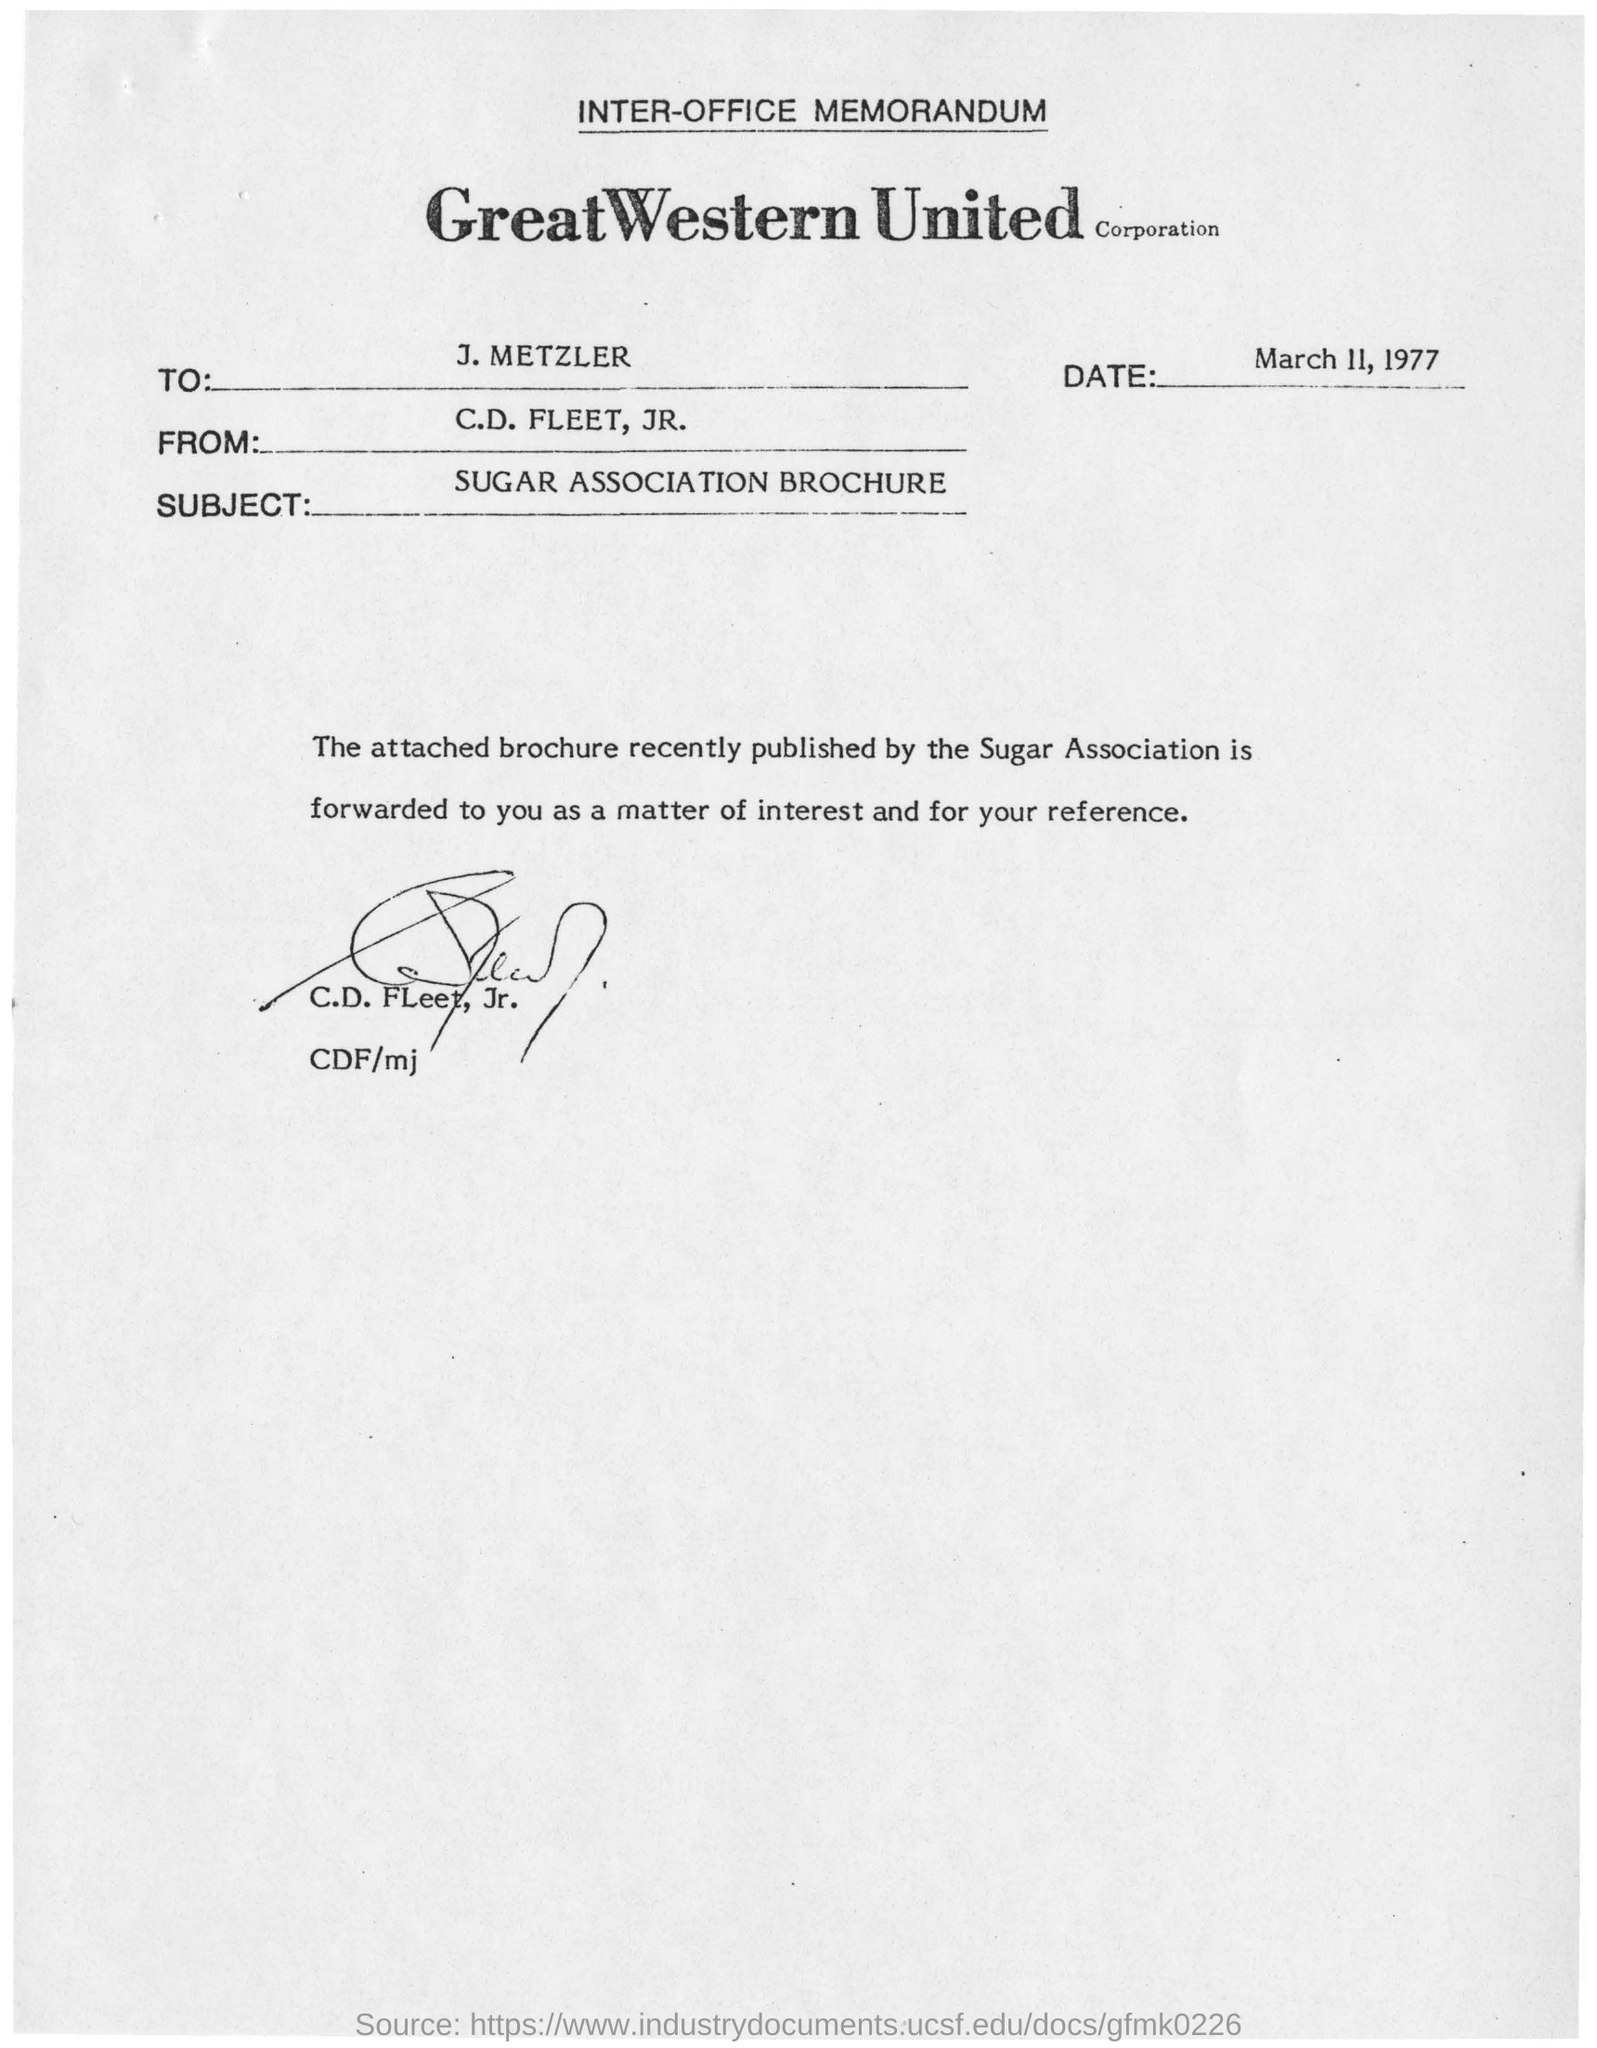What is the name of the corporation?
Ensure brevity in your answer.  Great western united corporation. What is the date mentioned in the memorandum?
Provide a short and direct response. March 11, 1977. Whom was the memorandum addressed to?
Give a very brief answer. J.metzler. Who is the sender of this memorandum?
Give a very brief answer. C.D. FLEET, JR. What is the subject of this memorandum?
Give a very brief answer. SUGAR ASSOCIATION BROUCHER. 